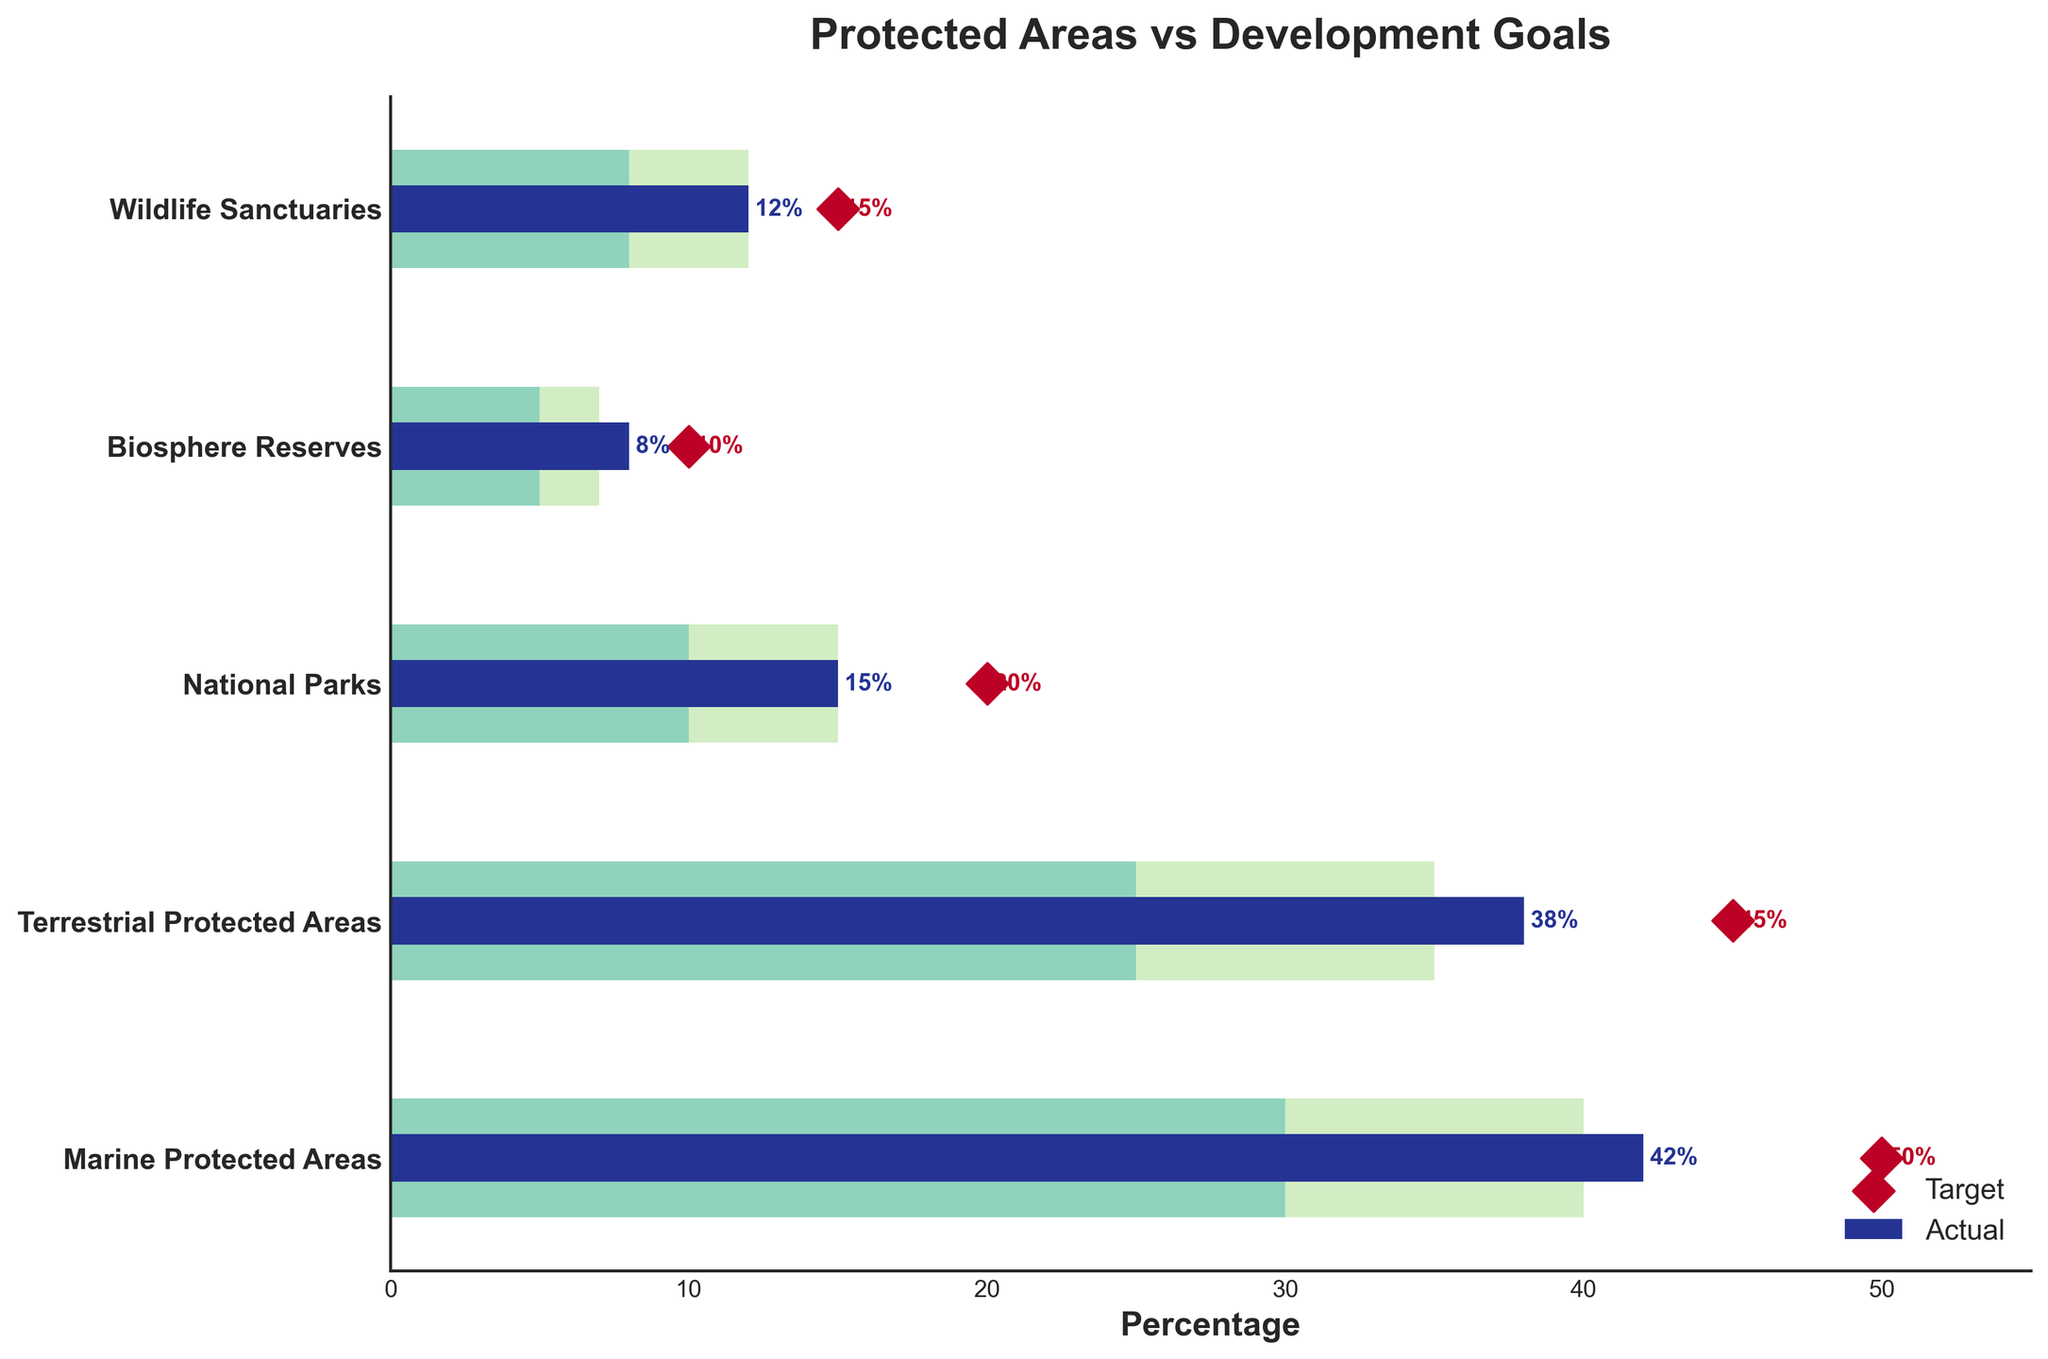What is the actual percentage of Marine Protected Areas? The actual percentage of Marine Protected Areas can be found in the figure where the corresponding data bar reaches 42% on the horizontal axis.
Answer: 42% What is the target percentage for Wildlife Sanctuaries? The target percentage for Wildlife Sanctuaries can be found by looking at the diamond marker on the horizontal axis next to "Wildlife Sanctuaries", which is at 15%.
Answer: 15% Which category has the smallest actual percentage? The smallest actual percentage can be identified by comparing the lengths of all the horizontal bars labeled "Actual". The bar for Biosphere Reserves is the shortest, reaching 8%.
Answer: Biosphere Reserves How many categories have their actual percentage above the satisfactory range but below the good range? We identify bars that end between the satisfactory and good ranges, marked by 30-40% for Marine, 25-35% for Terrestrial, 10-15% for National, 5-7% for Biosphere, and 8-12% for Wildlife. Two categories meet this criterion: Marine Protected Areas and Terrestrial Protected Areas.
Answer: 2 What is the difference between the actual and target percentages for Terrestrial Protected Areas? The actual percentage for Terrestrial Protected Areas is 38% and the target is 45%. The difference is calculated as 45 - 38.
Answer: 7% What is the total target percentage when combining National Parks and Biosphere Reserves? The target percentages for National Parks and Biosphere Reserves are 20% and 10%, respectively. Their sum is 20 + 10.
Answer: 30% Which category has exceeded the excellent range according to the figure? None of the actual percentage bars extend beyond the length of the corresponding "Good" range bars. All categories fall within or below their good range limits.
Answer: None How many categories have their actual percentages at or above half of the target percentage? For each category, half of the target percentage is 25 for Marine, 22.5 for Terrestrial, 10 for National, 5 for Biosphere, and 7.5 for Wildlife. Comparing these with the actual values 42, 38, 15, 8, and 12 respectively, all categories meet or exceed half of their targets.
Answer: 5 Which category is the farthest from reaching its target, in percentage points? Calculate the difference between the actual and target percentages for each category: Marine (50-42=8), Terrestrial (45-38=7), National (20-15=5), Biosphere (10-8=2), Wildlife (15-12=3). The Marine Protected Areas have the largest gap of 8 percentage points.
Answer: Marine Protected Areas 